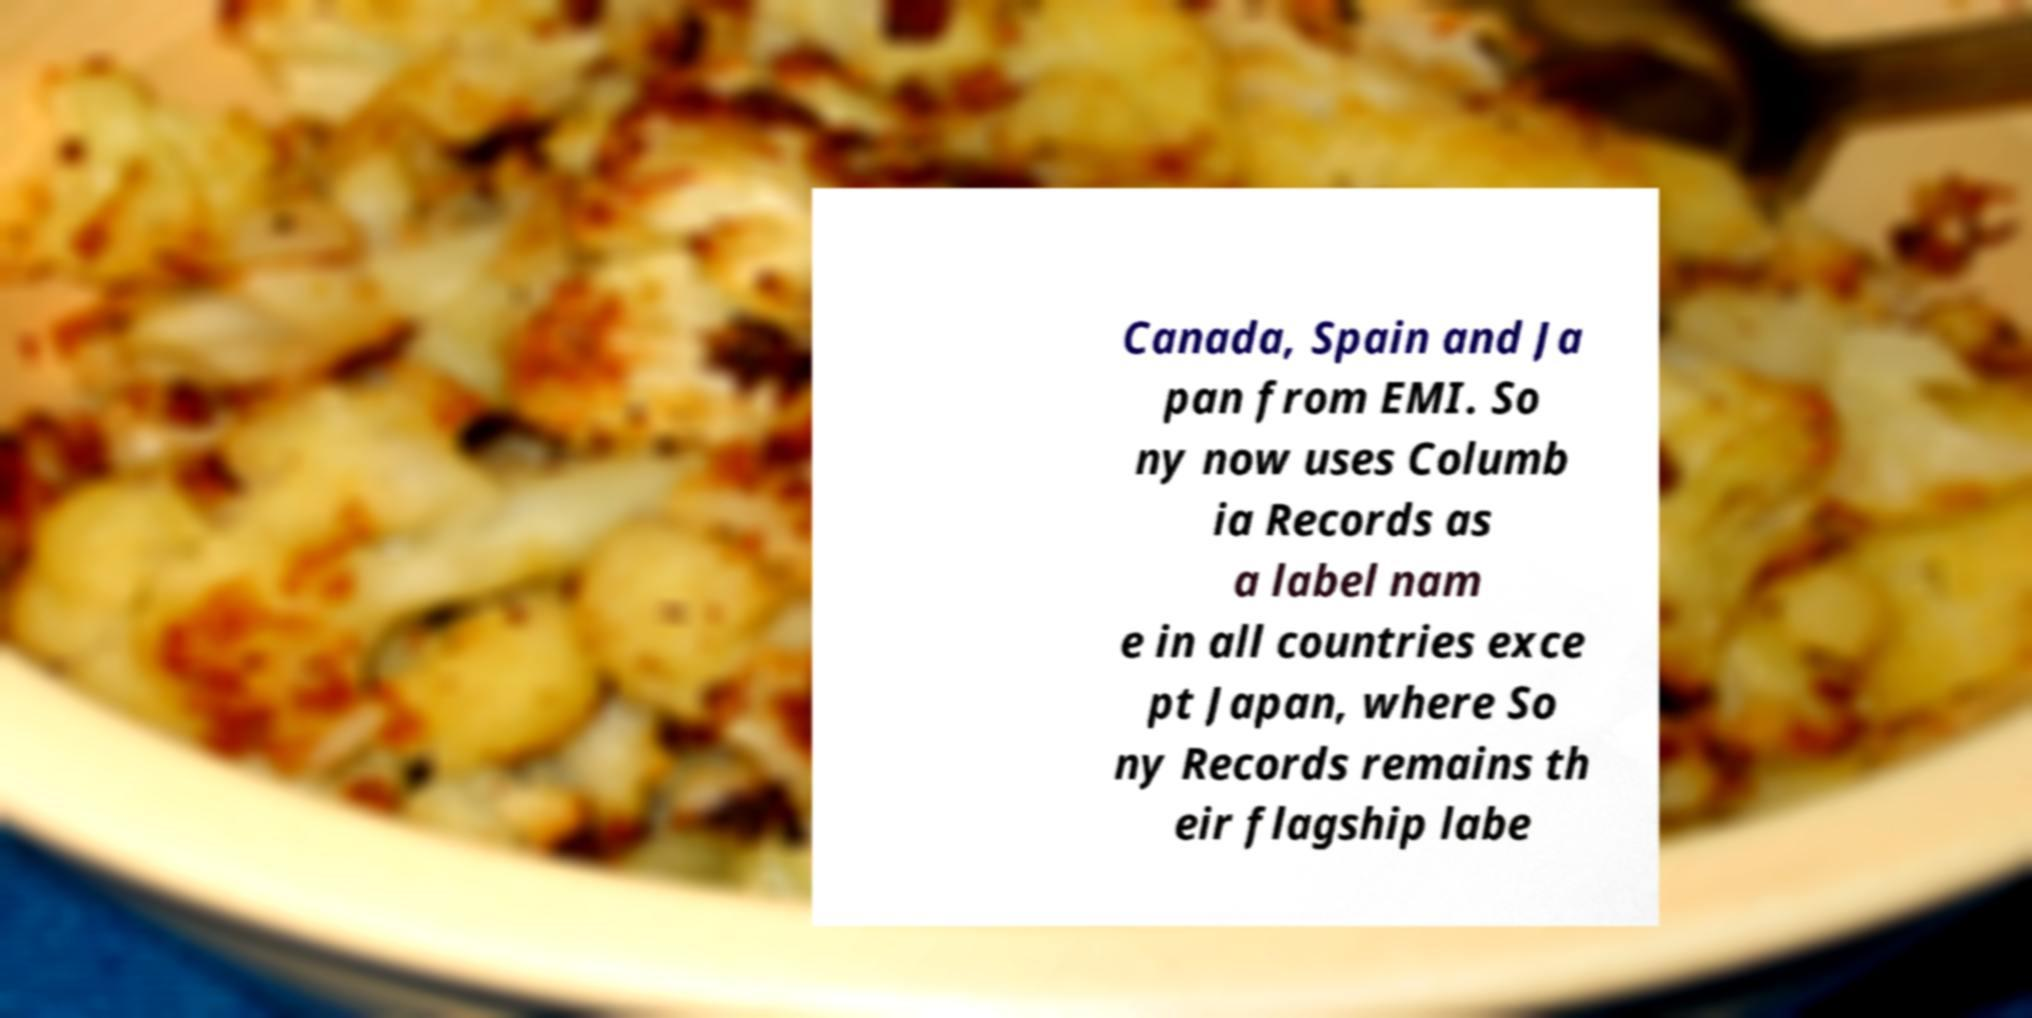Please identify and transcribe the text found in this image. Canada, Spain and Ja pan from EMI. So ny now uses Columb ia Records as a label nam e in all countries exce pt Japan, where So ny Records remains th eir flagship labe 